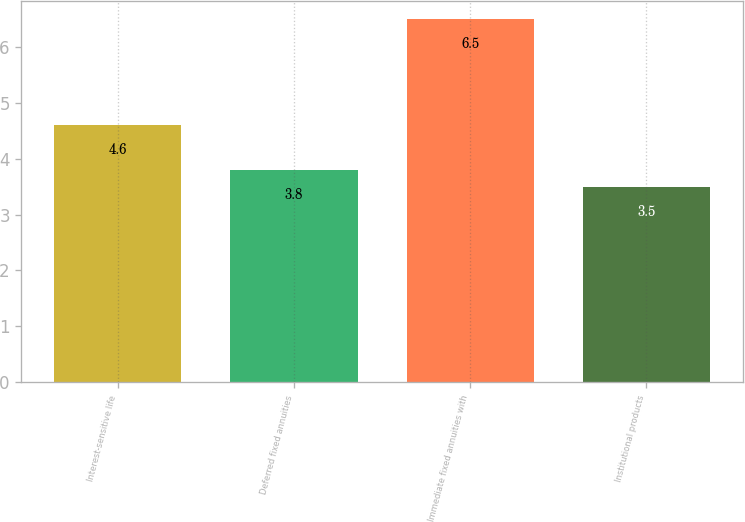Convert chart to OTSL. <chart><loc_0><loc_0><loc_500><loc_500><bar_chart><fcel>Interest-sensitive life<fcel>Deferred fixed annuities<fcel>Immediate fixed annuities with<fcel>Institutional products<nl><fcel>4.6<fcel>3.8<fcel>6.5<fcel>3.5<nl></chart> 